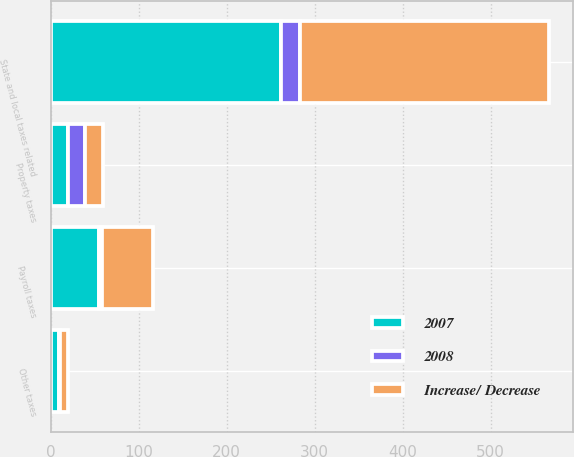<chart> <loc_0><loc_0><loc_500><loc_500><stacked_bar_chart><ecel><fcel>Property taxes<fcel>State and local taxes related<fcel>Payroll taxes<fcel>Other taxes<nl><fcel>Increase/ Decrease<fcel>20<fcel>283<fcel>58<fcel>9<nl><fcel>2007<fcel>20<fcel>262<fcel>55<fcel>10<nl><fcel>2008<fcel>19<fcel>21<fcel>3<fcel>1<nl></chart> 